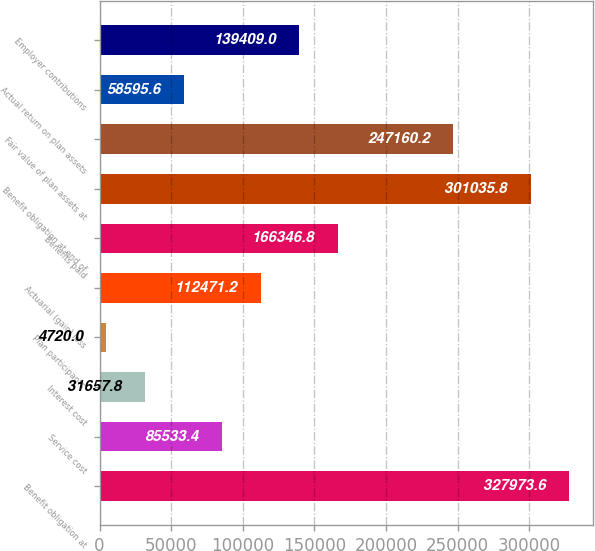<chart> <loc_0><loc_0><loc_500><loc_500><bar_chart><fcel>Benefit obligation at<fcel>Service cost<fcel>Interest cost<fcel>Plan participants'<fcel>Actuarial (gain) loss<fcel>Benefits paid<fcel>Benefit obligation at end of<fcel>Fair value of plan assets at<fcel>Actual return on plan assets<fcel>Employer contributions<nl><fcel>327974<fcel>85533.4<fcel>31657.8<fcel>4720<fcel>112471<fcel>166347<fcel>301036<fcel>247160<fcel>58595.6<fcel>139409<nl></chart> 